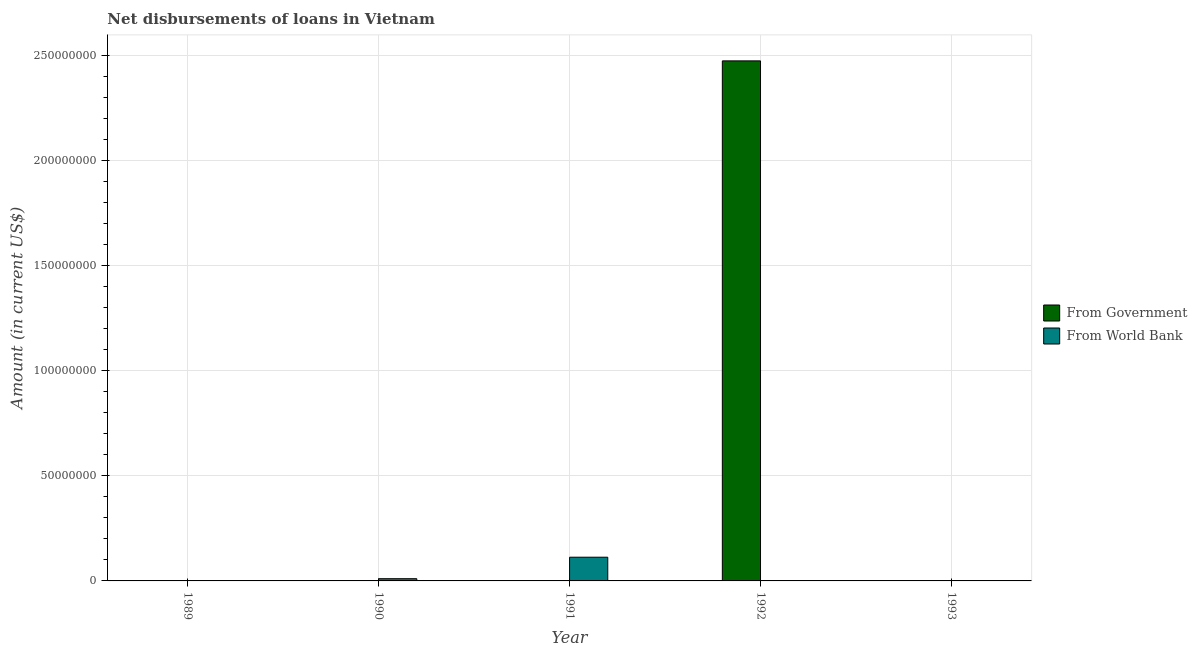How many different coloured bars are there?
Provide a short and direct response. 2. How many bars are there on the 4th tick from the left?
Give a very brief answer. 2. What is the label of the 3rd group of bars from the left?
Your answer should be compact. 1991. In how many cases, is the number of bars for a given year not equal to the number of legend labels?
Give a very brief answer. 4. What is the net disbursements of loan from world bank in 1990?
Offer a very short reply. 1.06e+06. Across all years, what is the maximum net disbursements of loan from world bank?
Your response must be concise. 1.13e+07. Across all years, what is the minimum net disbursements of loan from government?
Provide a short and direct response. 0. In which year was the net disbursements of loan from world bank maximum?
Give a very brief answer. 1991. What is the total net disbursements of loan from government in the graph?
Ensure brevity in your answer.  2.47e+08. What is the difference between the net disbursements of loan from world bank in 1990 and that in 1991?
Make the answer very short. -1.02e+07. What is the difference between the net disbursements of loan from government in 1991 and the net disbursements of loan from world bank in 1992?
Your answer should be very brief. -2.47e+08. What is the average net disbursements of loan from government per year?
Ensure brevity in your answer.  4.95e+07. In the year 1991, what is the difference between the net disbursements of loan from world bank and net disbursements of loan from government?
Offer a terse response. 0. In how many years, is the net disbursements of loan from world bank greater than 230000000 US$?
Provide a short and direct response. 0. What is the ratio of the net disbursements of loan from world bank in 1990 to that in 1991?
Make the answer very short. 0.09. What is the difference between the highest and the second highest net disbursements of loan from world bank?
Your answer should be very brief. 1.02e+07. What is the difference between the highest and the lowest net disbursements of loan from government?
Your answer should be compact. 2.47e+08. Is the sum of the net disbursements of loan from world bank in 1991 and 1992 greater than the maximum net disbursements of loan from government across all years?
Your response must be concise. Yes. What is the difference between two consecutive major ticks on the Y-axis?
Keep it short and to the point. 5.00e+07. Are the values on the major ticks of Y-axis written in scientific E-notation?
Offer a very short reply. No. Where does the legend appear in the graph?
Keep it short and to the point. Center right. How many legend labels are there?
Your response must be concise. 2. How are the legend labels stacked?
Provide a succinct answer. Vertical. What is the title of the graph?
Give a very brief answer. Net disbursements of loans in Vietnam. Does "Female labourers" appear as one of the legend labels in the graph?
Ensure brevity in your answer.  No. What is the label or title of the Y-axis?
Provide a succinct answer. Amount (in current US$). What is the Amount (in current US$) in From Government in 1989?
Your response must be concise. 0. What is the Amount (in current US$) of From World Bank in 1990?
Ensure brevity in your answer.  1.06e+06. What is the Amount (in current US$) in From Government in 1991?
Give a very brief answer. 0. What is the Amount (in current US$) of From World Bank in 1991?
Keep it short and to the point. 1.13e+07. What is the Amount (in current US$) in From Government in 1992?
Offer a terse response. 2.47e+08. What is the Amount (in current US$) of From World Bank in 1992?
Ensure brevity in your answer.  1.58e+05. What is the Amount (in current US$) in From Government in 1993?
Keep it short and to the point. 0. What is the Amount (in current US$) of From World Bank in 1993?
Your answer should be compact. 0. Across all years, what is the maximum Amount (in current US$) of From Government?
Provide a short and direct response. 2.47e+08. Across all years, what is the maximum Amount (in current US$) in From World Bank?
Offer a very short reply. 1.13e+07. Across all years, what is the minimum Amount (in current US$) in From Government?
Give a very brief answer. 0. What is the total Amount (in current US$) of From Government in the graph?
Provide a short and direct response. 2.47e+08. What is the total Amount (in current US$) of From World Bank in the graph?
Offer a very short reply. 1.25e+07. What is the difference between the Amount (in current US$) in From World Bank in 1990 and that in 1991?
Your response must be concise. -1.02e+07. What is the difference between the Amount (in current US$) in From World Bank in 1991 and that in 1992?
Provide a succinct answer. 1.11e+07. What is the average Amount (in current US$) in From Government per year?
Make the answer very short. 4.95e+07. What is the average Amount (in current US$) in From World Bank per year?
Make the answer very short. 2.50e+06. In the year 1992, what is the difference between the Amount (in current US$) of From Government and Amount (in current US$) of From World Bank?
Offer a terse response. 2.47e+08. What is the ratio of the Amount (in current US$) in From World Bank in 1990 to that in 1991?
Your response must be concise. 0.09. What is the ratio of the Amount (in current US$) of From World Bank in 1990 to that in 1992?
Your answer should be very brief. 6.7. What is the ratio of the Amount (in current US$) of From World Bank in 1991 to that in 1992?
Offer a very short reply. 71.37. What is the difference between the highest and the second highest Amount (in current US$) in From World Bank?
Your answer should be compact. 1.02e+07. What is the difference between the highest and the lowest Amount (in current US$) in From Government?
Provide a short and direct response. 2.47e+08. What is the difference between the highest and the lowest Amount (in current US$) in From World Bank?
Offer a terse response. 1.13e+07. 